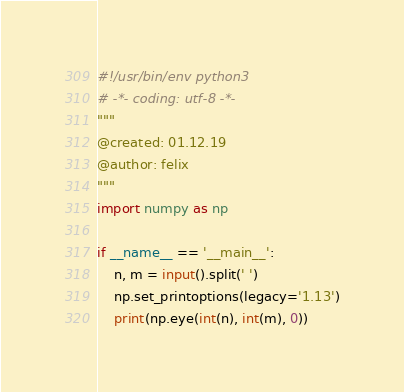Convert code to text. <code><loc_0><loc_0><loc_500><loc_500><_Python_>#!/usr/bin/env python3
# -*- coding: utf-8 -*-
"""
@created: 01.12.19
@author: felix
"""
import numpy as np

if __name__ == '__main__':
    n, m = input().split(' ')
    np.set_printoptions(legacy='1.13')
    print(np.eye(int(n), int(m), 0))
</code> 